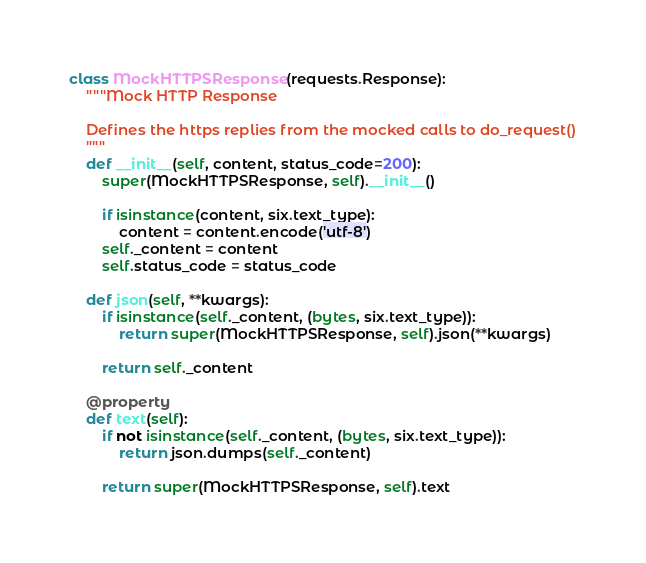<code> <loc_0><loc_0><loc_500><loc_500><_Python_>
class MockHTTPSResponse(requests.Response):
    """Mock HTTP Response

    Defines the https replies from the mocked calls to do_request()
    """
    def __init__(self, content, status_code=200):
        super(MockHTTPSResponse, self).__init__()

        if isinstance(content, six.text_type):
            content = content.encode('utf-8')
        self._content = content
        self.status_code = status_code

    def json(self, **kwargs):
        if isinstance(self._content, (bytes, six.text_type)):
            return super(MockHTTPSResponse, self).json(**kwargs)

        return self._content

    @property
    def text(self):
        if not isinstance(self._content, (bytes, six.text_type)):
            return json.dumps(self._content)

        return super(MockHTTPSResponse, self).text
</code> 